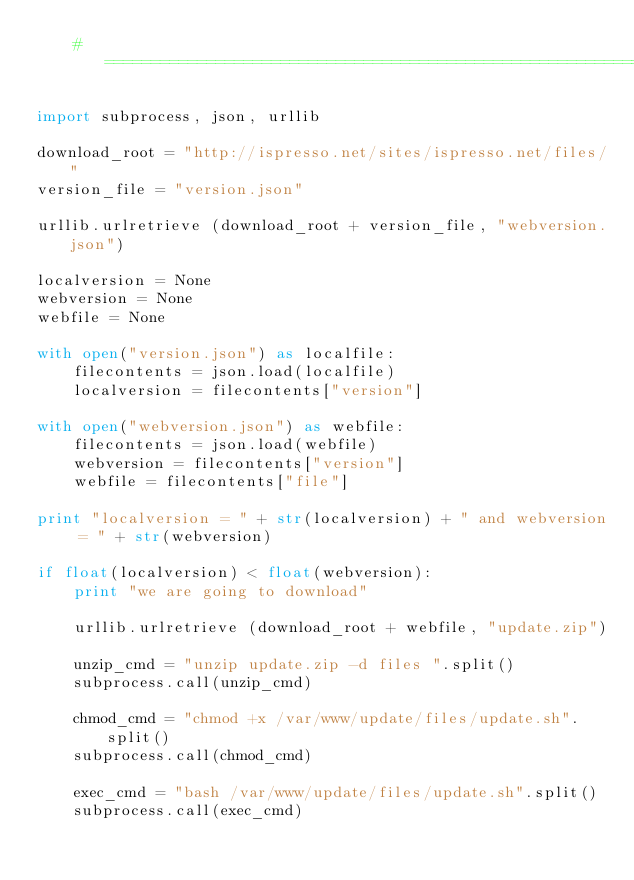<code> <loc_0><loc_0><loc_500><loc_500><_Python_>    #===========================================================================

import subprocess, json, urllib

download_root = "http://ispresso.net/sites/ispresso.net/files/"
version_file = "version.json"

urllib.urlretrieve (download_root + version_file, "webversion.json")

localversion = None
webversion = None
webfile = None

with open("version.json") as localfile:
    filecontents = json.load(localfile)
    localversion = filecontents["version"]
    
with open("webversion.json") as webfile:
    filecontents = json.load(webfile)
    webversion = filecontents["version"]
    webfile = filecontents["file"]

print "localversion = " + str(localversion) + " and webversion = " + str(webversion)

if float(localversion) < float(webversion):
    print "we are going to download"

    urllib.urlretrieve (download_root + webfile, "update.zip")

    unzip_cmd = "unzip update.zip -d files ".split()
    subprocess.call(unzip_cmd)
    
    chmod_cmd = "chmod +x /var/www/update/files/update.sh".split()
    subprocess.call(chmod_cmd)
    
    exec_cmd = "bash /var/www/update/files/update.sh".split()
    subprocess.call(exec_cmd)







</code> 